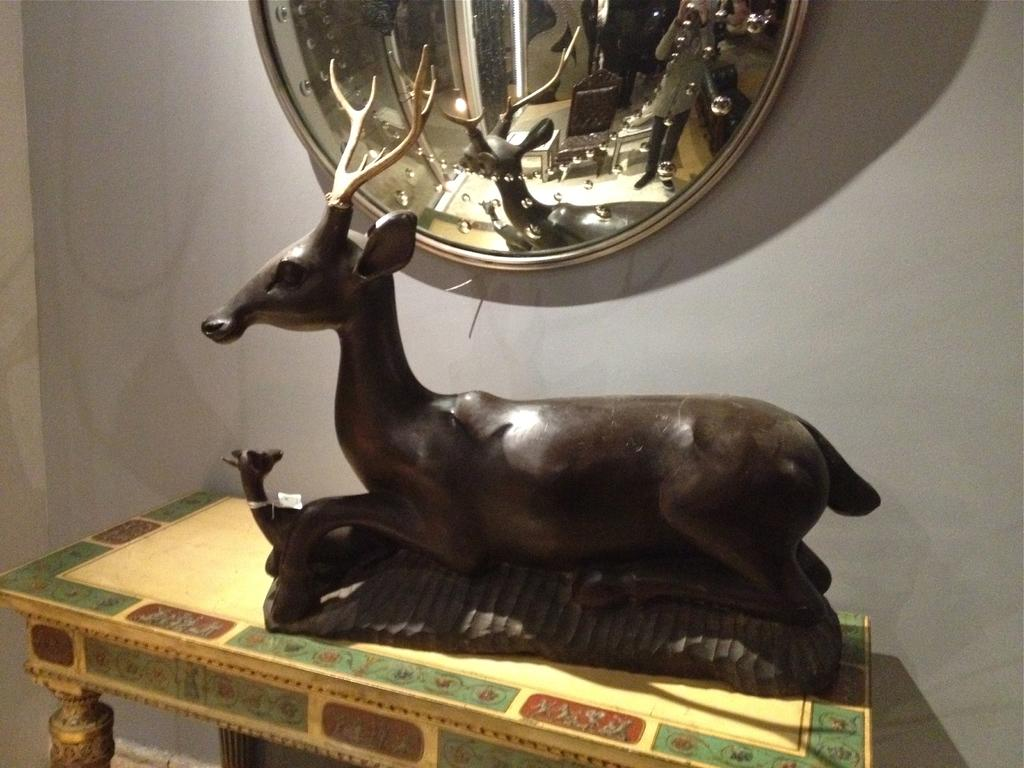What is the main subject of the image? There is a statue in the image. Where is the statue located? The statue is placed on a table. What other object can be seen in the image? There is a shield on a wall in the image. What type of creature is interacting with the statue in the image? There is no creature present in the image; it only features a statue on a table and a shield on a wall. 